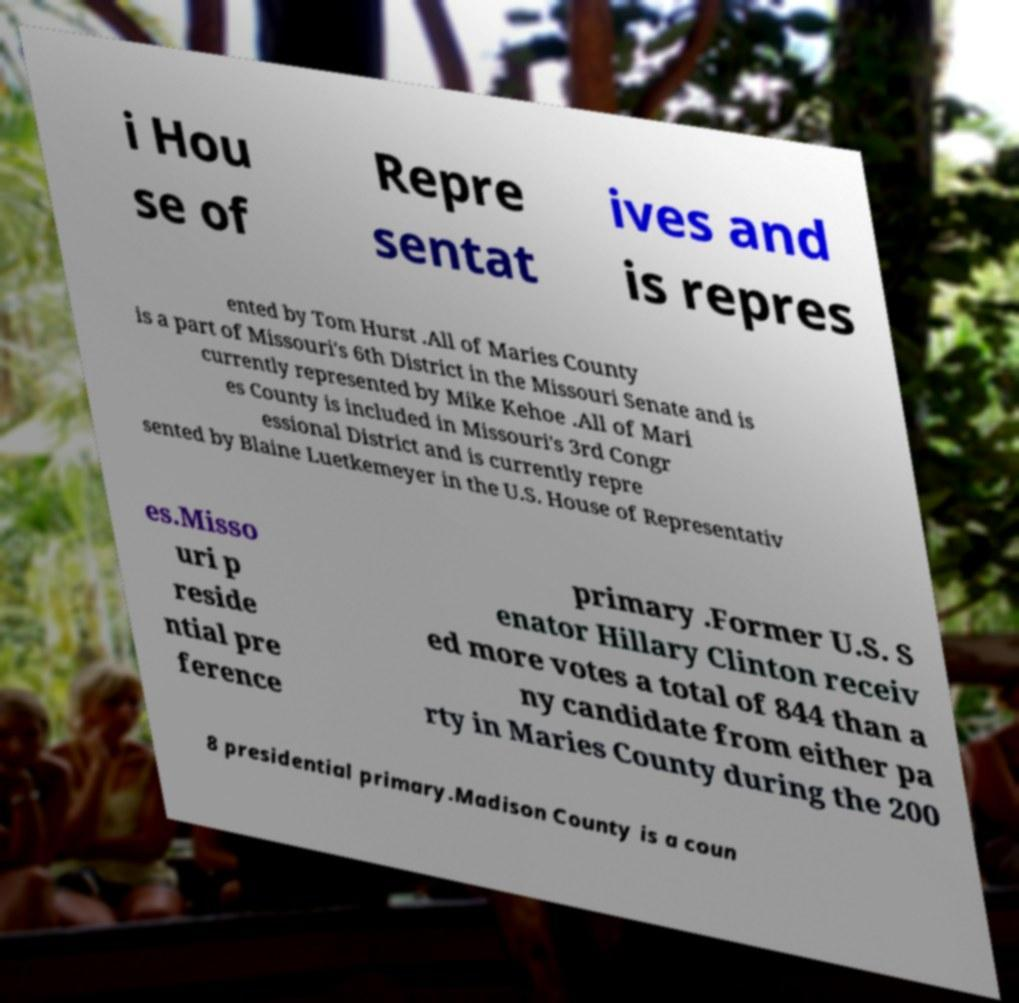Can you read and provide the text displayed in the image?This photo seems to have some interesting text. Can you extract and type it out for me? i Hou se of Repre sentat ives and is repres ented by Tom Hurst .All of Maries County is a part of Missouri's 6th District in the Missouri Senate and is currently represented by Mike Kehoe .All of Mari es County is included in Missouri's 3rd Congr essional District and is currently repre sented by Blaine Luetkemeyer in the U.S. House of Representativ es.Misso uri p reside ntial pre ference primary .Former U.S. S enator Hillary Clinton receiv ed more votes a total of 844 than a ny candidate from either pa rty in Maries County during the 200 8 presidential primary.Madison County is a coun 